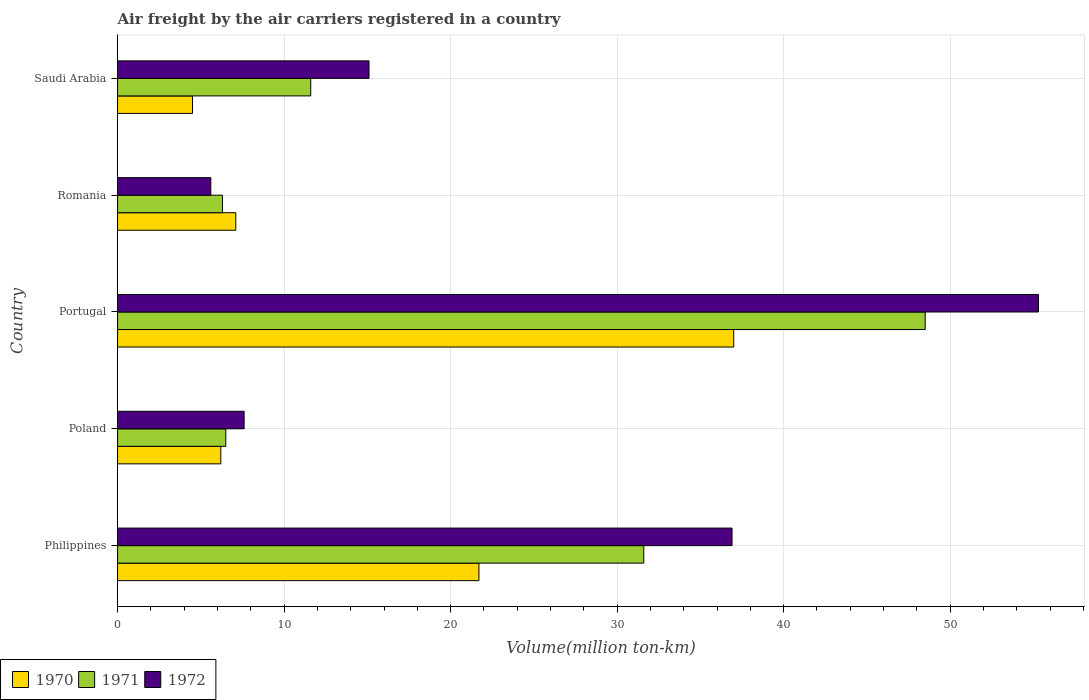How many groups of bars are there?
Offer a very short reply. 5. Are the number of bars on each tick of the Y-axis equal?
Offer a very short reply. Yes. What is the volume of the air carriers in 1970 in Portugal?
Keep it short and to the point. 37. Across all countries, what is the maximum volume of the air carriers in 1972?
Your response must be concise. 55.3. Across all countries, what is the minimum volume of the air carriers in 1971?
Give a very brief answer. 6.3. In which country was the volume of the air carriers in 1971 maximum?
Offer a terse response. Portugal. In which country was the volume of the air carriers in 1972 minimum?
Offer a terse response. Romania. What is the total volume of the air carriers in 1972 in the graph?
Your answer should be very brief. 120.5. What is the difference between the volume of the air carriers in 1972 in Portugal and that in Saudi Arabia?
Your answer should be compact. 40.2. What is the difference between the volume of the air carriers in 1972 in Romania and the volume of the air carriers in 1971 in Poland?
Make the answer very short. -0.9. What is the average volume of the air carriers in 1970 per country?
Your response must be concise. 15.3. What is the difference between the volume of the air carriers in 1970 and volume of the air carriers in 1971 in Romania?
Provide a short and direct response. 0.8. What is the ratio of the volume of the air carriers in 1971 in Philippines to that in Portugal?
Provide a succinct answer. 0.65. Is the difference between the volume of the air carriers in 1970 in Poland and Portugal greater than the difference between the volume of the air carriers in 1971 in Poland and Portugal?
Ensure brevity in your answer.  Yes. What is the difference between the highest and the second highest volume of the air carriers in 1970?
Offer a very short reply. 15.3. What is the difference between the highest and the lowest volume of the air carriers in 1972?
Keep it short and to the point. 49.7. Is the sum of the volume of the air carriers in 1971 in Philippines and Poland greater than the maximum volume of the air carriers in 1972 across all countries?
Your answer should be compact. No. What does the 1st bar from the bottom in Saudi Arabia represents?
Give a very brief answer. 1970. Are all the bars in the graph horizontal?
Give a very brief answer. Yes. How many countries are there in the graph?
Keep it short and to the point. 5. Does the graph contain any zero values?
Keep it short and to the point. No. Does the graph contain grids?
Keep it short and to the point. Yes. Where does the legend appear in the graph?
Give a very brief answer. Bottom left. What is the title of the graph?
Provide a short and direct response. Air freight by the air carriers registered in a country. Does "1967" appear as one of the legend labels in the graph?
Your answer should be very brief. No. What is the label or title of the X-axis?
Your answer should be very brief. Volume(million ton-km). What is the label or title of the Y-axis?
Offer a terse response. Country. What is the Volume(million ton-km) of 1970 in Philippines?
Offer a very short reply. 21.7. What is the Volume(million ton-km) in 1971 in Philippines?
Your response must be concise. 31.6. What is the Volume(million ton-km) of 1972 in Philippines?
Keep it short and to the point. 36.9. What is the Volume(million ton-km) of 1970 in Poland?
Provide a succinct answer. 6.2. What is the Volume(million ton-km) in 1972 in Poland?
Your answer should be very brief. 7.6. What is the Volume(million ton-km) of 1970 in Portugal?
Your response must be concise. 37. What is the Volume(million ton-km) of 1971 in Portugal?
Provide a succinct answer. 48.5. What is the Volume(million ton-km) of 1972 in Portugal?
Ensure brevity in your answer.  55.3. What is the Volume(million ton-km) of 1970 in Romania?
Ensure brevity in your answer.  7.1. What is the Volume(million ton-km) in 1971 in Romania?
Your answer should be compact. 6.3. What is the Volume(million ton-km) of 1972 in Romania?
Provide a short and direct response. 5.6. What is the Volume(million ton-km) in 1970 in Saudi Arabia?
Offer a very short reply. 4.5. What is the Volume(million ton-km) of 1971 in Saudi Arabia?
Your answer should be very brief. 11.6. What is the Volume(million ton-km) in 1972 in Saudi Arabia?
Your answer should be very brief. 15.1. Across all countries, what is the maximum Volume(million ton-km) in 1971?
Keep it short and to the point. 48.5. Across all countries, what is the maximum Volume(million ton-km) of 1972?
Provide a succinct answer. 55.3. Across all countries, what is the minimum Volume(million ton-km) of 1971?
Give a very brief answer. 6.3. Across all countries, what is the minimum Volume(million ton-km) of 1972?
Your answer should be compact. 5.6. What is the total Volume(million ton-km) in 1970 in the graph?
Provide a succinct answer. 76.5. What is the total Volume(million ton-km) in 1971 in the graph?
Provide a succinct answer. 104.5. What is the total Volume(million ton-km) in 1972 in the graph?
Give a very brief answer. 120.5. What is the difference between the Volume(million ton-km) of 1971 in Philippines and that in Poland?
Keep it short and to the point. 25.1. What is the difference between the Volume(million ton-km) of 1972 in Philippines and that in Poland?
Provide a succinct answer. 29.3. What is the difference between the Volume(million ton-km) of 1970 in Philippines and that in Portugal?
Provide a succinct answer. -15.3. What is the difference between the Volume(million ton-km) of 1971 in Philippines and that in Portugal?
Offer a terse response. -16.9. What is the difference between the Volume(million ton-km) of 1972 in Philippines and that in Portugal?
Your answer should be compact. -18.4. What is the difference between the Volume(million ton-km) of 1970 in Philippines and that in Romania?
Keep it short and to the point. 14.6. What is the difference between the Volume(million ton-km) of 1971 in Philippines and that in Romania?
Give a very brief answer. 25.3. What is the difference between the Volume(million ton-km) in 1972 in Philippines and that in Romania?
Give a very brief answer. 31.3. What is the difference between the Volume(million ton-km) in 1971 in Philippines and that in Saudi Arabia?
Offer a terse response. 20. What is the difference between the Volume(million ton-km) of 1972 in Philippines and that in Saudi Arabia?
Give a very brief answer. 21.8. What is the difference between the Volume(million ton-km) of 1970 in Poland and that in Portugal?
Give a very brief answer. -30.8. What is the difference between the Volume(million ton-km) of 1971 in Poland and that in Portugal?
Offer a terse response. -42. What is the difference between the Volume(million ton-km) in 1972 in Poland and that in Portugal?
Provide a succinct answer. -47.7. What is the difference between the Volume(million ton-km) in 1970 in Poland and that in Romania?
Offer a terse response. -0.9. What is the difference between the Volume(million ton-km) in 1972 in Poland and that in Romania?
Your answer should be compact. 2. What is the difference between the Volume(million ton-km) in 1970 in Portugal and that in Romania?
Provide a short and direct response. 29.9. What is the difference between the Volume(million ton-km) in 1971 in Portugal and that in Romania?
Your answer should be very brief. 42.2. What is the difference between the Volume(million ton-km) in 1972 in Portugal and that in Romania?
Offer a very short reply. 49.7. What is the difference between the Volume(million ton-km) of 1970 in Portugal and that in Saudi Arabia?
Your response must be concise. 32.5. What is the difference between the Volume(million ton-km) in 1971 in Portugal and that in Saudi Arabia?
Make the answer very short. 36.9. What is the difference between the Volume(million ton-km) in 1972 in Portugal and that in Saudi Arabia?
Make the answer very short. 40.2. What is the difference between the Volume(million ton-km) of 1970 in Romania and that in Saudi Arabia?
Your response must be concise. 2.6. What is the difference between the Volume(million ton-km) of 1970 in Philippines and the Volume(million ton-km) of 1971 in Portugal?
Offer a very short reply. -26.8. What is the difference between the Volume(million ton-km) in 1970 in Philippines and the Volume(million ton-km) in 1972 in Portugal?
Give a very brief answer. -33.6. What is the difference between the Volume(million ton-km) in 1971 in Philippines and the Volume(million ton-km) in 1972 in Portugal?
Offer a terse response. -23.7. What is the difference between the Volume(million ton-km) in 1971 in Philippines and the Volume(million ton-km) in 1972 in Saudi Arabia?
Provide a succinct answer. 16.5. What is the difference between the Volume(million ton-km) of 1970 in Poland and the Volume(million ton-km) of 1971 in Portugal?
Offer a terse response. -42.3. What is the difference between the Volume(million ton-km) in 1970 in Poland and the Volume(million ton-km) in 1972 in Portugal?
Your answer should be very brief. -49.1. What is the difference between the Volume(million ton-km) in 1971 in Poland and the Volume(million ton-km) in 1972 in Portugal?
Provide a succinct answer. -48.8. What is the difference between the Volume(million ton-km) in 1970 in Poland and the Volume(million ton-km) in 1971 in Romania?
Make the answer very short. -0.1. What is the difference between the Volume(million ton-km) in 1970 in Poland and the Volume(million ton-km) in 1972 in Romania?
Provide a short and direct response. 0.6. What is the difference between the Volume(million ton-km) of 1970 in Poland and the Volume(million ton-km) of 1971 in Saudi Arabia?
Offer a terse response. -5.4. What is the difference between the Volume(million ton-km) of 1970 in Poland and the Volume(million ton-km) of 1972 in Saudi Arabia?
Your response must be concise. -8.9. What is the difference between the Volume(million ton-km) in 1971 in Poland and the Volume(million ton-km) in 1972 in Saudi Arabia?
Provide a succinct answer. -8.6. What is the difference between the Volume(million ton-km) in 1970 in Portugal and the Volume(million ton-km) in 1971 in Romania?
Offer a terse response. 30.7. What is the difference between the Volume(million ton-km) of 1970 in Portugal and the Volume(million ton-km) of 1972 in Romania?
Give a very brief answer. 31.4. What is the difference between the Volume(million ton-km) in 1971 in Portugal and the Volume(million ton-km) in 1972 in Romania?
Your response must be concise. 42.9. What is the difference between the Volume(million ton-km) of 1970 in Portugal and the Volume(million ton-km) of 1971 in Saudi Arabia?
Offer a very short reply. 25.4. What is the difference between the Volume(million ton-km) in 1970 in Portugal and the Volume(million ton-km) in 1972 in Saudi Arabia?
Offer a terse response. 21.9. What is the difference between the Volume(million ton-km) in 1971 in Portugal and the Volume(million ton-km) in 1972 in Saudi Arabia?
Your answer should be compact. 33.4. What is the difference between the Volume(million ton-km) of 1970 in Romania and the Volume(million ton-km) of 1971 in Saudi Arabia?
Your answer should be very brief. -4.5. What is the difference between the Volume(million ton-km) in 1971 in Romania and the Volume(million ton-km) in 1972 in Saudi Arabia?
Ensure brevity in your answer.  -8.8. What is the average Volume(million ton-km) of 1971 per country?
Make the answer very short. 20.9. What is the average Volume(million ton-km) of 1972 per country?
Your answer should be very brief. 24.1. What is the difference between the Volume(million ton-km) in 1970 and Volume(million ton-km) in 1971 in Philippines?
Offer a very short reply. -9.9. What is the difference between the Volume(million ton-km) of 1970 and Volume(million ton-km) of 1972 in Philippines?
Offer a very short reply. -15.2. What is the difference between the Volume(million ton-km) of 1971 and Volume(million ton-km) of 1972 in Philippines?
Your answer should be compact. -5.3. What is the difference between the Volume(million ton-km) of 1971 and Volume(million ton-km) of 1972 in Poland?
Give a very brief answer. -1.1. What is the difference between the Volume(million ton-km) of 1970 and Volume(million ton-km) of 1971 in Portugal?
Make the answer very short. -11.5. What is the difference between the Volume(million ton-km) in 1970 and Volume(million ton-km) in 1972 in Portugal?
Provide a succinct answer. -18.3. What is the difference between the Volume(million ton-km) of 1971 and Volume(million ton-km) of 1972 in Portugal?
Ensure brevity in your answer.  -6.8. What is the difference between the Volume(million ton-km) of 1970 and Volume(million ton-km) of 1971 in Romania?
Your answer should be compact. 0.8. What is the difference between the Volume(million ton-km) in 1970 and Volume(million ton-km) in 1972 in Romania?
Your answer should be compact. 1.5. What is the difference between the Volume(million ton-km) in 1971 and Volume(million ton-km) in 1972 in Romania?
Your response must be concise. 0.7. What is the difference between the Volume(million ton-km) in 1970 and Volume(million ton-km) in 1971 in Saudi Arabia?
Your answer should be compact. -7.1. What is the difference between the Volume(million ton-km) of 1971 and Volume(million ton-km) of 1972 in Saudi Arabia?
Your response must be concise. -3.5. What is the ratio of the Volume(million ton-km) of 1970 in Philippines to that in Poland?
Offer a terse response. 3.5. What is the ratio of the Volume(million ton-km) in 1971 in Philippines to that in Poland?
Keep it short and to the point. 4.86. What is the ratio of the Volume(million ton-km) in 1972 in Philippines to that in Poland?
Offer a very short reply. 4.86. What is the ratio of the Volume(million ton-km) of 1970 in Philippines to that in Portugal?
Make the answer very short. 0.59. What is the ratio of the Volume(million ton-km) in 1971 in Philippines to that in Portugal?
Offer a very short reply. 0.65. What is the ratio of the Volume(million ton-km) in 1972 in Philippines to that in Portugal?
Keep it short and to the point. 0.67. What is the ratio of the Volume(million ton-km) of 1970 in Philippines to that in Romania?
Offer a very short reply. 3.06. What is the ratio of the Volume(million ton-km) in 1971 in Philippines to that in Romania?
Provide a short and direct response. 5.02. What is the ratio of the Volume(million ton-km) of 1972 in Philippines to that in Romania?
Keep it short and to the point. 6.59. What is the ratio of the Volume(million ton-km) in 1970 in Philippines to that in Saudi Arabia?
Give a very brief answer. 4.82. What is the ratio of the Volume(million ton-km) of 1971 in Philippines to that in Saudi Arabia?
Provide a succinct answer. 2.72. What is the ratio of the Volume(million ton-km) in 1972 in Philippines to that in Saudi Arabia?
Offer a very short reply. 2.44. What is the ratio of the Volume(million ton-km) of 1970 in Poland to that in Portugal?
Your response must be concise. 0.17. What is the ratio of the Volume(million ton-km) in 1971 in Poland to that in Portugal?
Make the answer very short. 0.13. What is the ratio of the Volume(million ton-km) of 1972 in Poland to that in Portugal?
Give a very brief answer. 0.14. What is the ratio of the Volume(million ton-km) of 1970 in Poland to that in Romania?
Provide a succinct answer. 0.87. What is the ratio of the Volume(million ton-km) of 1971 in Poland to that in Romania?
Offer a very short reply. 1.03. What is the ratio of the Volume(million ton-km) in 1972 in Poland to that in Romania?
Ensure brevity in your answer.  1.36. What is the ratio of the Volume(million ton-km) in 1970 in Poland to that in Saudi Arabia?
Ensure brevity in your answer.  1.38. What is the ratio of the Volume(million ton-km) of 1971 in Poland to that in Saudi Arabia?
Offer a terse response. 0.56. What is the ratio of the Volume(million ton-km) in 1972 in Poland to that in Saudi Arabia?
Provide a succinct answer. 0.5. What is the ratio of the Volume(million ton-km) in 1970 in Portugal to that in Romania?
Make the answer very short. 5.21. What is the ratio of the Volume(million ton-km) of 1971 in Portugal to that in Romania?
Give a very brief answer. 7.7. What is the ratio of the Volume(million ton-km) of 1972 in Portugal to that in Romania?
Provide a succinct answer. 9.88. What is the ratio of the Volume(million ton-km) of 1970 in Portugal to that in Saudi Arabia?
Keep it short and to the point. 8.22. What is the ratio of the Volume(million ton-km) of 1971 in Portugal to that in Saudi Arabia?
Make the answer very short. 4.18. What is the ratio of the Volume(million ton-km) of 1972 in Portugal to that in Saudi Arabia?
Offer a very short reply. 3.66. What is the ratio of the Volume(million ton-km) in 1970 in Romania to that in Saudi Arabia?
Your response must be concise. 1.58. What is the ratio of the Volume(million ton-km) of 1971 in Romania to that in Saudi Arabia?
Provide a succinct answer. 0.54. What is the ratio of the Volume(million ton-km) in 1972 in Romania to that in Saudi Arabia?
Provide a short and direct response. 0.37. What is the difference between the highest and the second highest Volume(million ton-km) of 1970?
Provide a succinct answer. 15.3. What is the difference between the highest and the second highest Volume(million ton-km) of 1971?
Provide a succinct answer. 16.9. What is the difference between the highest and the lowest Volume(million ton-km) of 1970?
Provide a short and direct response. 32.5. What is the difference between the highest and the lowest Volume(million ton-km) of 1971?
Your response must be concise. 42.2. What is the difference between the highest and the lowest Volume(million ton-km) in 1972?
Your answer should be compact. 49.7. 